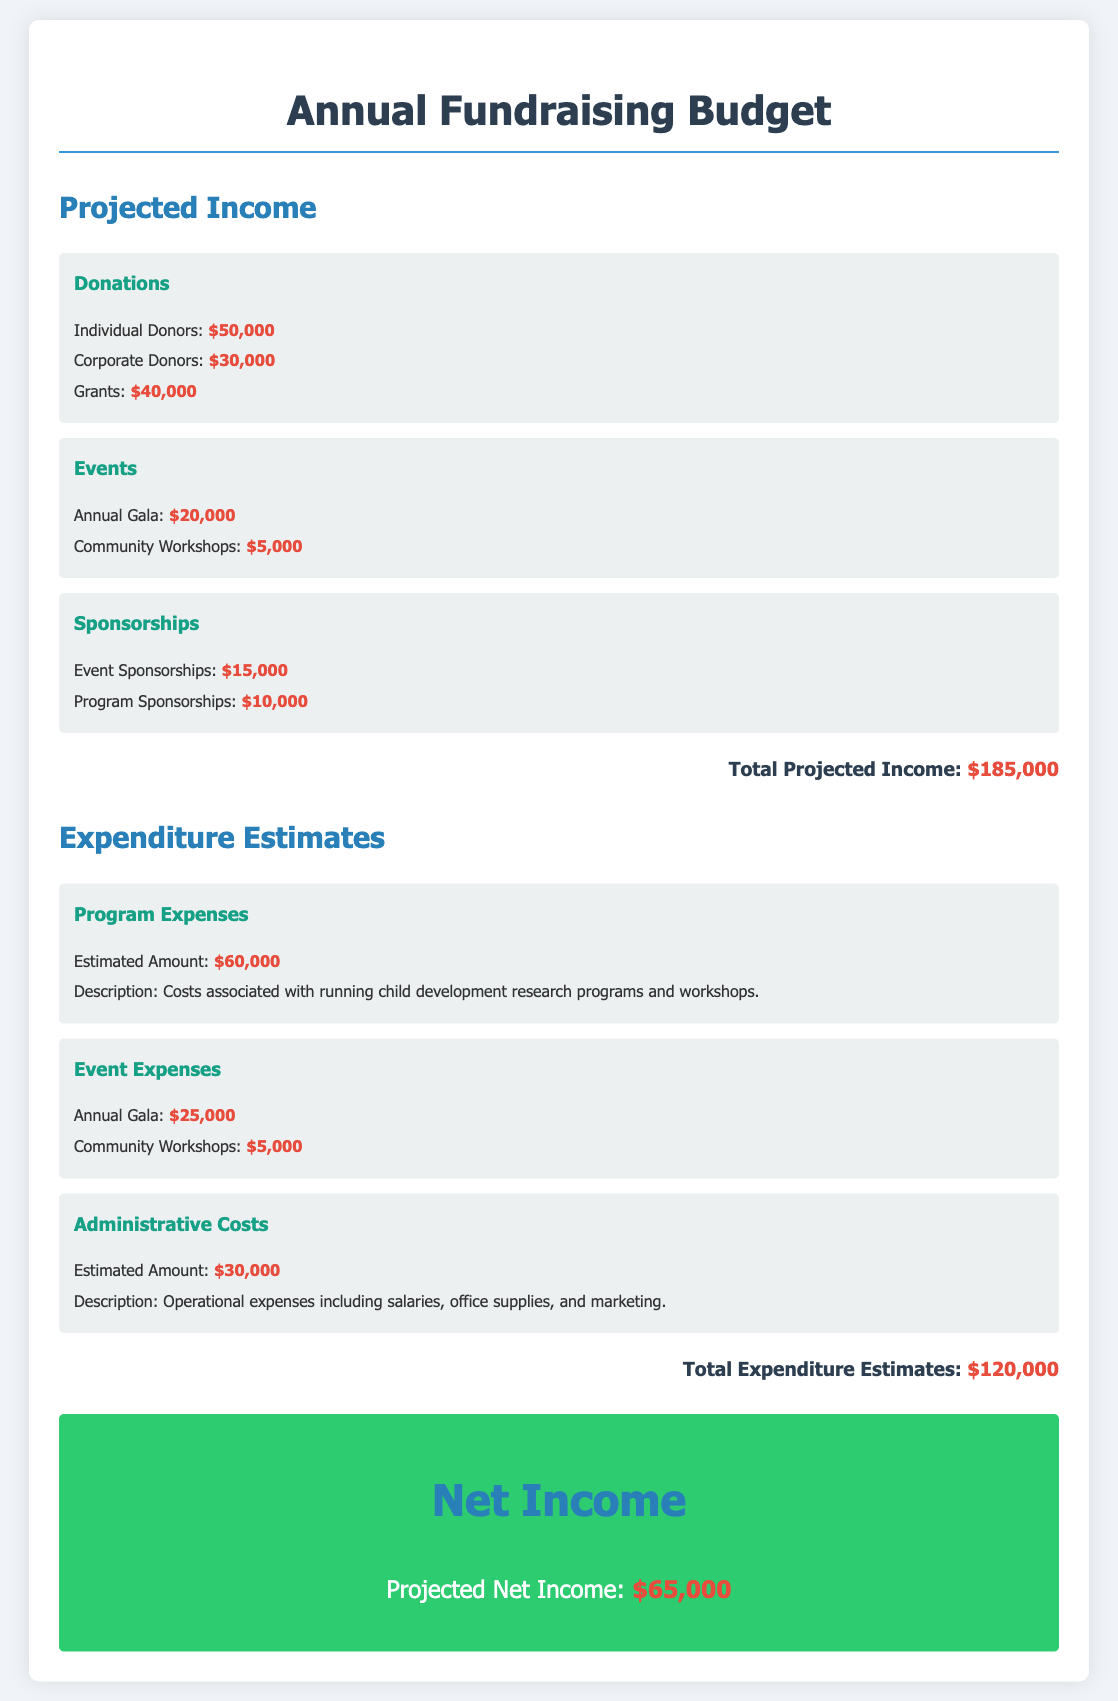what is the total projected income? The total projected income is calculated by adding all income sources listed in the document, which amounts to $185,000.
Answer: $185,000 how much is allocated for grants? The budget specifies an amount of $40,000 for grants under the donations section.
Answer: $40,000 what are the anticipated program expenses? The anticipated program expenses are detailed in the budget, totaling $60,000.
Answer: $60,000 how much do event sponsorships contribute? Event sponsorships contribute a total of $15,000 to the projected income.
Answer: $15,000 what is the estimated amount for administrative costs? The estimated amount for administrative costs is given as $30,000 in the expenditure estimates section.
Answer: $30,000 what is the net income projected for the year? The net income projected for the year is calculated as total projected income minus total expenditure estimates, resulting in $65,000.
Answer: $65,000 how much is expected from the annual gala? The budget shows that the annual gala is expected to generate $20,000 in income.
Answer: $20,000 what is the total expenditure estimate? The total expenditure estimate is the sum of all expense categories, which equals $120,000.
Answer: $120,000 how much is allocated for community workshops in expenses? The budget allocates $5,000 for community workshops under event expenses.
Answer: $5,000 